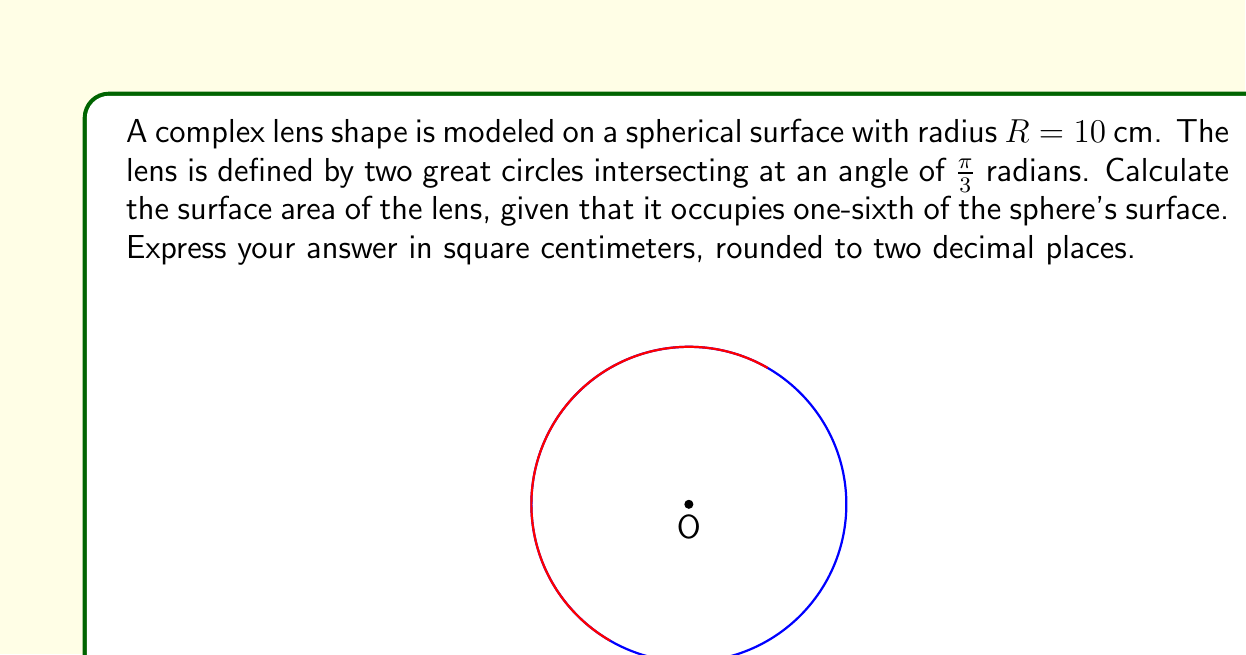Can you solve this math problem? To solve this problem, we'll follow these steps:

1) First, recall the formula for the surface area of a sphere:
   $$A_{sphere} = 4\pi R^2$$

2) Given $R = 10$ cm, we can calculate the total surface area:
   $$A_{sphere} = 4\pi (10)^2 = 400\pi \text{ cm}^2$$

3) The lens occupies one-sixth of the sphere's surface. Therefore, its area is:
   $$A_{lens} = \frac{1}{6} \cdot 400\pi = \frac{200\pi}{3} \text{ cm}^2$$

4) To evaluate this:
   $$\frac{200\pi}{3} \approx 209.4395 \text{ cm}^2$$

5) Rounding to two decimal places:
   $$A_{lens} \approx 209.44 \text{ cm}^2$$

This approach uses the property that the area of a spherical triangle (which is what our lens shape is) is proportional to the angle between its great circles, relative to a full great circle ($2\pi$ radians). In this case, $\frac{\pi}{3}$ is one-sixth of $2\pi$, hence the lens occupies one-sixth of the sphere's surface.
Answer: $209.44 \text{ cm}^2$ 